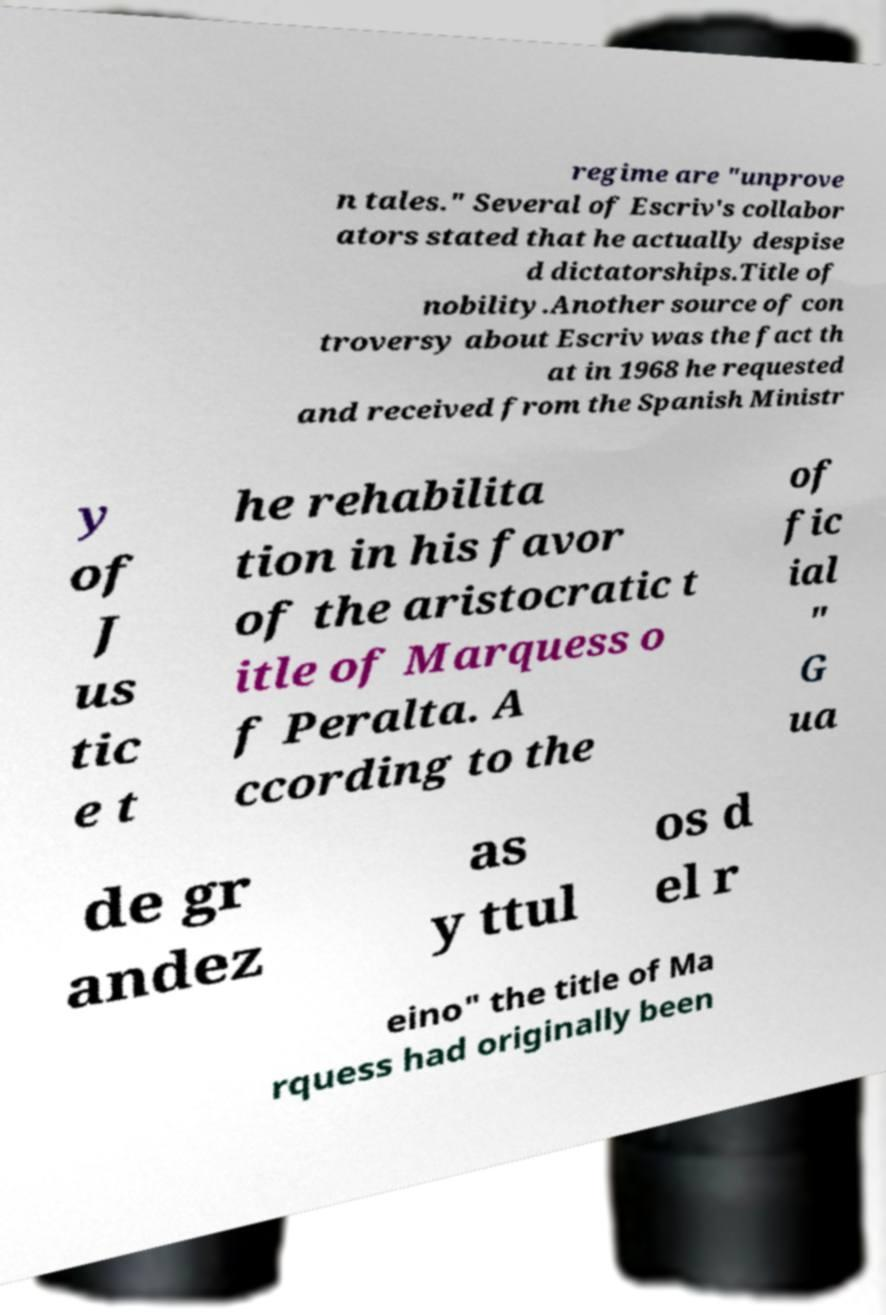Please identify and transcribe the text found in this image. regime are "unprove n tales." Several of Escriv's collabor ators stated that he actually despise d dictatorships.Title of nobility.Another source of con troversy about Escriv was the fact th at in 1968 he requested and received from the Spanish Ministr y of J us tic e t he rehabilita tion in his favor of the aristocratic t itle of Marquess o f Peralta. A ccording to the of fic ial " G ua de gr andez as y ttul os d el r eino" the title of Ma rquess had originally been 